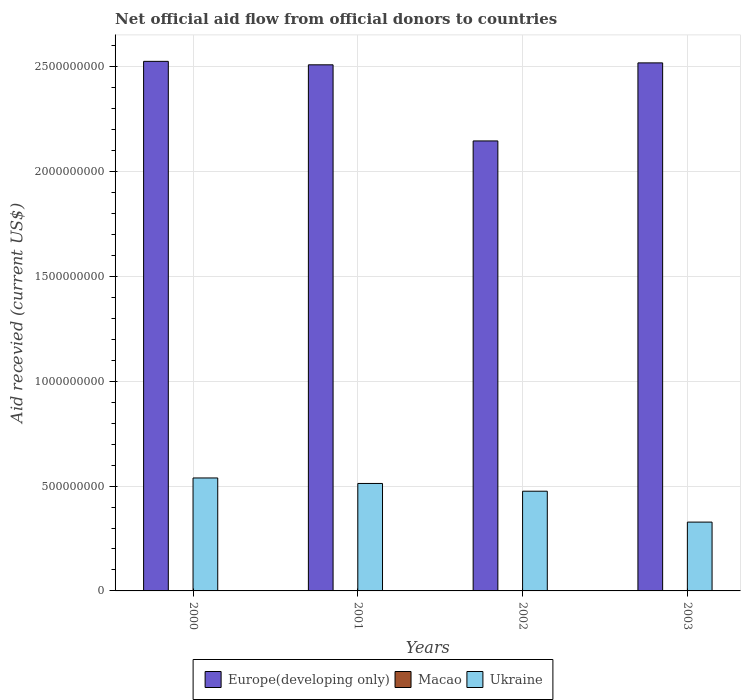How many different coloured bars are there?
Your answer should be compact. 3. How many groups of bars are there?
Your answer should be very brief. 4. Are the number of bars per tick equal to the number of legend labels?
Provide a short and direct response. Yes. How many bars are there on the 1st tick from the right?
Ensure brevity in your answer.  3. In how many cases, is the number of bars for a given year not equal to the number of legend labels?
Offer a terse response. 0. What is the total aid received in Ukraine in 2001?
Offer a very short reply. 5.12e+08. Across all years, what is the maximum total aid received in Europe(developing only)?
Keep it short and to the point. 2.53e+09. Across all years, what is the minimum total aid received in Macao?
Keep it short and to the point. 1.30e+05. In which year was the total aid received in Macao maximum?
Your answer should be very brief. 2002. What is the total total aid received in Ukraine in the graph?
Your response must be concise. 1.85e+09. What is the difference between the total aid received in Europe(developing only) in 2000 and the total aid received in Macao in 2002?
Provide a succinct answer. 2.52e+09. What is the average total aid received in Macao per year?
Keep it short and to the point. 5.80e+05. In the year 2002, what is the difference between the total aid received in Ukraine and total aid received in Macao?
Provide a short and direct response. 4.75e+08. In how many years, is the total aid received in Ukraine greater than 1400000000 US$?
Provide a succinct answer. 0. What is the ratio of the total aid received in Europe(developing only) in 2002 to that in 2003?
Give a very brief answer. 0.85. Is the total aid received in Ukraine in 2001 less than that in 2003?
Your response must be concise. No. What is the difference between the highest and the second highest total aid received in Ukraine?
Offer a terse response. 2.62e+07. What is the difference between the highest and the lowest total aid received in Macao?
Keep it short and to the point. 8.50e+05. In how many years, is the total aid received in Ukraine greater than the average total aid received in Ukraine taken over all years?
Provide a succinct answer. 3. Is the sum of the total aid received in Ukraine in 2001 and 2003 greater than the maximum total aid received in Europe(developing only) across all years?
Offer a very short reply. No. What does the 2nd bar from the left in 2001 represents?
Ensure brevity in your answer.  Macao. What does the 1st bar from the right in 2002 represents?
Offer a terse response. Ukraine. Are all the bars in the graph horizontal?
Your response must be concise. No. What is the difference between two consecutive major ticks on the Y-axis?
Make the answer very short. 5.00e+08. Are the values on the major ticks of Y-axis written in scientific E-notation?
Ensure brevity in your answer.  No. How many legend labels are there?
Your answer should be very brief. 3. How are the legend labels stacked?
Your response must be concise. Horizontal. What is the title of the graph?
Offer a terse response. Net official aid flow from official donors to countries. What is the label or title of the X-axis?
Provide a short and direct response. Years. What is the label or title of the Y-axis?
Keep it short and to the point. Aid recevied (current US$). What is the Aid recevied (current US$) in Europe(developing only) in 2000?
Give a very brief answer. 2.53e+09. What is the Aid recevied (current US$) in Macao in 2000?
Make the answer very short. 6.80e+05. What is the Aid recevied (current US$) in Ukraine in 2000?
Provide a succinct answer. 5.39e+08. What is the Aid recevied (current US$) in Europe(developing only) in 2001?
Keep it short and to the point. 2.51e+09. What is the Aid recevied (current US$) in Macao in 2001?
Keep it short and to the point. 5.30e+05. What is the Aid recevied (current US$) in Ukraine in 2001?
Offer a terse response. 5.12e+08. What is the Aid recevied (current US$) in Europe(developing only) in 2002?
Ensure brevity in your answer.  2.15e+09. What is the Aid recevied (current US$) in Macao in 2002?
Give a very brief answer. 9.80e+05. What is the Aid recevied (current US$) in Ukraine in 2002?
Your answer should be compact. 4.76e+08. What is the Aid recevied (current US$) of Europe(developing only) in 2003?
Your answer should be very brief. 2.52e+09. What is the Aid recevied (current US$) of Ukraine in 2003?
Give a very brief answer. 3.28e+08. Across all years, what is the maximum Aid recevied (current US$) in Europe(developing only)?
Make the answer very short. 2.53e+09. Across all years, what is the maximum Aid recevied (current US$) in Macao?
Offer a terse response. 9.80e+05. Across all years, what is the maximum Aid recevied (current US$) of Ukraine?
Your answer should be very brief. 5.39e+08. Across all years, what is the minimum Aid recevied (current US$) in Europe(developing only)?
Your answer should be very brief. 2.15e+09. Across all years, what is the minimum Aid recevied (current US$) of Macao?
Provide a succinct answer. 1.30e+05. Across all years, what is the minimum Aid recevied (current US$) of Ukraine?
Your answer should be compact. 3.28e+08. What is the total Aid recevied (current US$) in Europe(developing only) in the graph?
Provide a short and direct response. 9.70e+09. What is the total Aid recevied (current US$) of Macao in the graph?
Provide a succinct answer. 2.32e+06. What is the total Aid recevied (current US$) of Ukraine in the graph?
Provide a short and direct response. 1.85e+09. What is the difference between the Aid recevied (current US$) of Europe(developing only) in 2000 and that in 2001?
Offer a terse response. 1.65e+07. What is the difference between the Aid recevied (current US$) in Ukraine in 2000 and that in 2001?
Provide a succinct answer. 2.62e+07. What is the difference between the Aid recevied (current US$) in Europe(developing only) in 2000 and that in 2002?
Your answer should be very brief. 3.80e+08. What is the difference between the Aid recevied (current US$) in Ukraine in 2000 and that in 2002?
Provide a succinct answer. 6.32e+07. What is the difference between the Aid recevied (current US$) of Europe(developing only) in 2000 and that in 2003?
Your response must be concise. 7.31e+06. What is the difference between the Aid recevied (current US$) of Ukraine in 2000 and that in 2003?
Your answer should be compact. 2.10e+08. What is the difference between the Aid recevied (current US$) in Europe(developing only) in 2001 and that in 2002?
Offer a very short reply. 3.63e+08. What is the difference between the Aid recevied (current US$) of Macao in 2001 and that in 2002?
Your answer should be very brief. -4.50e+05. What is the difference between the Aid recevied (current US$) in Ukraine in 2001 and that in 2002?
Make the answer very short. 3.69e+07. What is the difference between the Aid recevied (current US$) in Europe(developing only) in 2001 and that in 2003?
Provide a succinct answer. -9.21e+06. What is the difference between the Aid recevied (current US$) of Macao in 2001 and that in 2003?
Ensure brevity in your answer.  4.00e+05. What is the difference between the Aid recevied (current US$) in Ukraine in 2001 and that in 2003?
Your response must be concise. 1.84e+08. What is the difference between the Aid recevied (current US$) in Europe(developing only) in 2002 and that in 2003?
Make the answer very short. -3.72e+08. What is the difference between the Aid recevied (current US$) in Macao in 2002 and that in 2003?
Keep it short and to the point. 8.50e+05. What is the difference between the Aid recevied (current US$) in Ukraine in 2002 and that in 2003?
Make the answer very short. 1.47e+08. What is the difference between the Aid recevied (current US$) in Europe(developing only) in 2000 and the Aid recevied (current US$) in Macao in 2001?
Provide a succinct answer. 2.53e+09. What is the difference between the Aid recevied (current US$) in Europe(developing only) in 2000 and the Aid recevied (current US$) in Ukraine in 2001?
Ensure brevity in your answer.  2.01e+09. What is the difference between the Aid recevied (current US$) of Macao in 2000 and the Aid recevied (current US$) of Ukraine in 2001?
Ensure brevity in your answer.  -5.12e+08. What is the difference between the Aid recevied (current US$) in Europe(developing only) in 2000 and the Aid recevied (current US$) in Macao in 2002?
Give a very brief answer. 2.52e+09. What is the difference between the Aid recevied (current US$) in Europe(developing only) in 2000 and the Aid recevied (current US$) in Ukraine in 2002?
Offer a very short reply. 2.05e+09. What is the difference between the Aid recevied (current US$) of Macao in 2000 and the Aid recevied (current US$) of Ukraine in 2002?
Ensure brevity in your answer.  -4.75e+08. What is the difference between the Aid recevied (current US$) in Europe(developing only) in 2000 and the Aid recevied (current US$) in Macao in 2003?
Your answer should be compact. 2.53e+09. What is the difference between the Aid recevied (current US$) in Europe(developing only) in 2000 and the Aid recevied (current US$) in Ukraine in 2003?
Give a very brief answer. 2.20e+09. What is the difference between the Aid recevied (current US$) of Macao in 2000 and the Aid recevied (current US$) of Ukraine in 2003?
Provide a short and direct response. -3.28e+08. What is the difference between the Aid recevied (current US$) of Europe(developing only) in 2001 and the Aid recevied (current US$) of Macao in 2002?
Ensure brevity in your answer.  2.51e+09. What is the difference between the Aid recevied (current US$) of Europe(developing only) in 2001 and the Aid recevied (current US$) of Ukraine in 2002?
Your answer should be compact. 2.03e+09. What is the difference between the Aid recevied (current US$) in Macao in 2001 and the Aid recevied (current US$) in Ukraine in 2002?
Provide a short and direct response. -4.75e+08. What is the difference between the Aid recevied (current US$) of Europe(developing only) in 2001 and the Aid recevied (current US$) of Macao in 2003?
Offer a terse response. 2.51e+09. What is the difference between the Aid recevied (current US$) of Europe(developing only) in 2001 and the Aid recevied (current US$) of Ukraine in 2003?
Your answer should be compact. 2.18e+09. What is the difference between the Aid recevied (current US$) of Macao in 2001 and the Aid recevied (current US$) of Ukraine in 2003?
Your answer should be compact. -3.28e+08. What is the difference between the Aid recevied (current US$) in Europe(developing only) in 2002 and the Aid recevied (current US$) in Macao in 2003?
Your response must be concise. 2.15e+09. What is the difference between the Aid recevied (current US$) of Europe(developing only) in 2002 and the Aid recevied (current US$) of Ukraine in 2003?
Offer a very short reply. 1.82e+09. What is the difference between the Aid recevied (current US$) in Macao in 2002 and the Aid recevied (current US$) in Ukraine in 2003?
Ensure brevity in your answer.  -3.27e+08. What is the average Aid recevied (current US$) in Europe(developing only) per year?
Give a very brief answer. 2.42e+09. What is the average Aid recevied (current US$) of Macao per year?
Keep it short and to the point. 5.80e+05. What is the average Aid recevied (current US$) in Ukraine per year?
Offer a very short reply. 4.64e+08. In the year 2000, what is the difference between the Aid recevied (current US$) in Europe(developing only) and Aid recevied (current US$) in Macao?
Your response must be concise. 2.52e+09. In the year 2000, what is the difference between the Aid recevied (current US$) of Europe(developing only) and Aid recevied (current US$) of Ukraine?
Provide a succinct answer. 1.99e+09. In the year 2000, what is the difference between the Aid recevied (current US$) of Macao and Aid recevied (current US$) of Ukraine?
Keep it short and to the point. -5.38e+08. In the year 2001, what is the difference between the Aid recevied (current US$) in Europe(developing only) and Aid recevied (current US$) in Macao?
Give a very brief answer. 2.51e+09. In the year 2001, what is the difference between the Aid recevied (current US$) of Europe(developing only) and Aid recevied (current US$) of Ukraine?
Your response must be concise. 2.00e+09. In the year 2001, what is the difference between the Aid recevied (current US$) in Macao and Aid recevied (current US$) in Ukraine?
Make the answer very short. -5.12e+08. In the year 2002, what is the difference between the Aid recevied (current US$) in Europe(developing only) and Aid recevied (current US$) in Macao?
Offer a terse response. 2.15e+09. In the year 2002, what is the difference between the Aid recevied (current US$) in Europe(developing only) and Aid recevied (current US$) in Ukraine?
Ensure brevity in your answer.  1.67e+09. In the year 2002, what is the difference between the Aid recevied (current US$) of Macao and Aid recevied (current US$) of Ukraine?
Ensure brevity in your answer.  -4.75e+08. In the year 2003, what is the difference between the Aid recevied (current US$) in Europe(developing only) and Aid recevied (current US$) in Macao?
Give a very brief answer. 2.52e+09. In the year 2003, what is the difference between the Aid recevied (current US$) in Europe(developing only) and Aid recevied (current US$) in Ukraine?
Make the answer very short. 2.19e+09. In the year 2003, what is the difference between the Aid recevied (current US$) in Macao and Aid recevied (current US$) in Ukraine?
Your answer should be very brief. -3.28e+08. What is the ratio of the Aid recevied (current US$) in Europe(developing only) in 2000 to that in 2001?
Your response must be concise. 1.01. What is the ratio of the Aid recevied (current US$) in Macao in 2000 to that in 2001?
Keep it short and to the point. 1.28. What is the ratio of the Aid recevied (current US$) of Ukraine in 2000 to that in 2001?
Give a very brief answer. 1.05. What is the ratio of the Aid recevied (current US$) in Europe(developing only) in 2000 to that in 2002?
Give a very brief answer. 1.18. What is the ratio of the Aid recevied (current US$) of Macao in 2000 to that in 2002?
Offer a terse response. 0.69. What is the ratio of the Aid recevied (current US$) in Ukraine in 2000 to that in 2002?
Provide a short and direct response. 1.13. What is the ratio of the Aid recevied (current US$) of Macao in 2000 to that in 2003?
Give a very brief answer. 5.23. What is the ratio of the Aid recevied (current US$) of Ukraine in 2000 to that in 2003?
Offer a very short reply. 1.64. What is the ratio of the Aid recevied (current US$) in Europe(developing only) in 2001 to that in 2002?
Offer a very short reply. 1.17. What is the ratio of the Aid recevied (current US$) of Macao in 2001 to that in 2002?
Your response must be concise. 0.54. What is the ratio of the Aid recevied (current US$) in Ukraine in 2001 to that in 2002?
Your response must be concise. 1.08. What is the ratio of the Aid recevied (current US$) in Europe(developing only) in 2001 to that in 2003?
Your response must be concise. 1. What is the ratio of the Aid recevied (current US$) of Macao in 2001 to that in 2003?
Make the answer very short. 4.08. What is the ratio of the Aid recevied (current US$) of Ukraine in 2001 to that in 2003?
Your answer should be very brief. 1.56. What is the ratio of the Aid recevied (current US$) of Europe(developing only) in 2002 to that in 2003?
Ensure brevity in your answer.  0.85. What is the ratio of the Aid recevied (current US$) of Macao in 2002 to that in 2003?
Make the answer very short. 7.54. What is the ratio of the Aid recevied (current US$) of Ukraine in 2002 to that in 2003?
Your answer should be very brief. 1.45. What is the difference between the highest and the second highest Aid recevied (current US$) of Europe(developing only)?
Your answer should be compact. 7.31e+06. What is the difference between the highest and the second highest Aid recevied (current US$) of Macao?
Provide a short and direct response. 3.00e+05. What is the difference between the highest and the second highest Aid recevied (current US$) in Ukraine?
Offer a very short reply. 2.62e+07. What is the difference between the highest and the lowest Aid recevied (current US$) in Europe(developing only)?
Provide a succinct answer. 3.80e+08. What is the difference between the highest and the lowest Aid recevied (current US$) in Macao?
Your answer should be very brief. 8.50e+05. What is the difference between the highest and the lowest Aid recevied (current US$) in Ukraine?
Ensure brevity in your answer.  2.10e+08. 